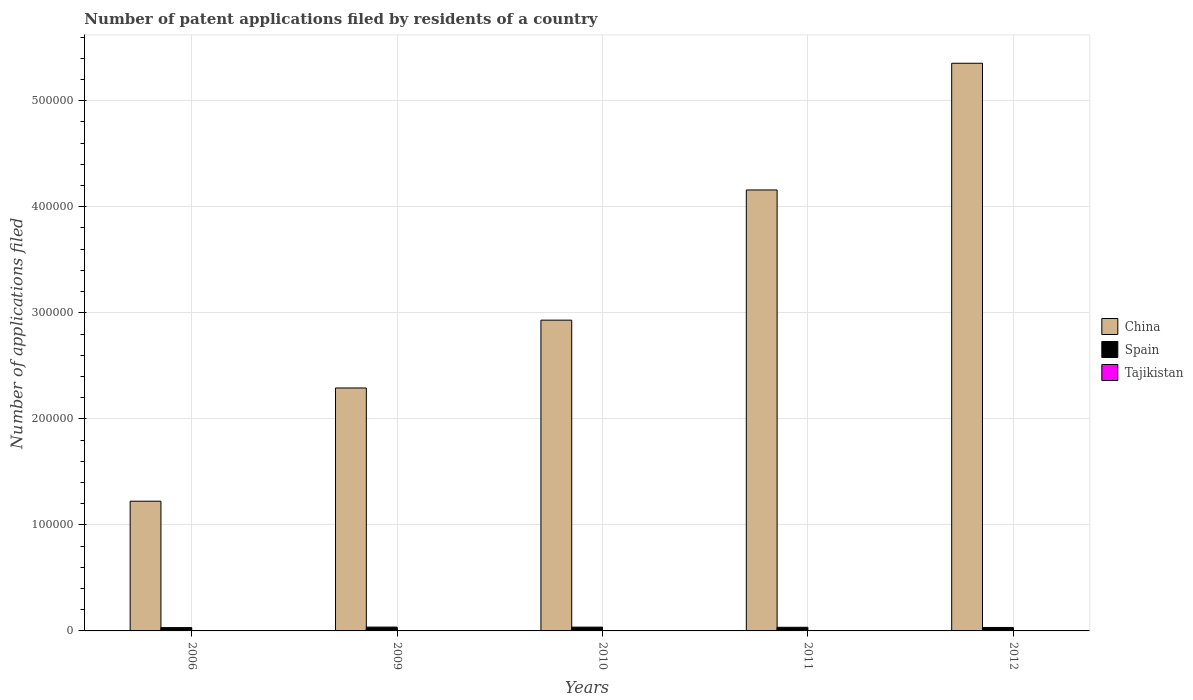How many groups of bars are there?
Your response must be concise. 5. Are the number of bars on each tick of the X-axis equal?
Your answer should be compact. Yes. What is the number of applications filed in China in 2010?
Offer a very short reply. 2.93e+05. Across all years, what is the maximum number of applications filed in China?
Offer a very short reply. 5.35e+05. Across all years, what is the minimum number of applications filed in China?
Provide a short and direct response. 1.22e+05. In which year was the number of applications filed in Spain maximum?
Keep it short and to the point. 2009. In which year was the number of applications filed in Spain minimum?
Make the answer very short. 2006. What is the total number of applications filed in Spain in the graph?
Offer a very short reply. 1.70e+04. What is the difference between the number of applications filed in China in 2009 and that in 2011?
Your answer should be very brief. -1.87e+05. What is the difference between the number of applications filed in Spain in 2011 and the number of applications filed in Tajikistan in 2010?
Provide a short and direct response. 3423. What is the average number of applications filed in China per year?
Make the answer very short. 3.19e+05. In the year 2006, what is the difference between the number of applications filed in China and number of applications filed in Tajikistan?
Offer a terse response. 1.22e+05. In how many years, is the number of applications filed in Spain greater than 60000?
Offer a terse response. 0. What is the ratio of the number of applications filed in Spain in 2011 to that in 2012?
Keep it short and to the point. 1.05. Is the number of applications filed in Tajikistan in 2009 less than that in 2011?
Your answer should be compact. No. Is the difference between the number of applications filed in China in 2006 and 2009 greater than the difference between the number of applications filed in Tajikistan in 2006 and 2009?
Provide a short and direct response. No. What is the difference between the highest and the second highest number of applications filed in China?
Ensure brevity in your answer.  1.19e+05. What is the difference between the highest and the lowest number of applications filed in Tajikistan?
Ensure brevity in your answer.  23. What does the 1st bar from the right in 2006 represents?
Make the answer very short. Tajikistan. How many bars are there?
Your answer should be compact. 15. How many years are there in the graph?
Offer a terse response. 5. What is the difference between two consecutive major ticks on the Y-axis?
Keep it short and to the point. 1.00e+05. Does the graph contain any zero values?
Your response must be concise. No. Where does the legend appear in the graph?
Your answer should be compact. Center right. What is the title of the graph?
Give a very brief answer. Number of patent applications filed by residents of a country. What is the label or title of the X-axis?
Offer a terse response. Years. What is the label or title of the Y-axis?
Offer a terse response. Number of applications filed. What is the Number of applications filed of China in 2006?
Your response must be concise. 1.22e+05. What is the Number of applications filed of Spain in 2006?
Provide a succinct answer. 3111. What is the Number of applications filed of Tajikistan in 2006?
Make the answer very short. 26. What is the Number of applications filed in China in 2009?
Provide a short and direct response. 2.29e+05. What is the Number of applications filed of Spain in 2009?
Your answer should be very brief. 3596. What is the Number of applications filed in China in 2010?
Provide a succinct answer. 2.93e+05. What is the Number of applications filed in Spain in 2010?
Keep it short and to the point. 3566. What is the Number of applications filed of Tajikistan in 2010?
Your answer should be compact. 7. What is the Number of applications filed of China in 2011?
Offer a terse response. 4.16e+05. What is the Number of applications filed of Spain in 2011?
Provide a short and direct response. 3430. What is the Number of applications filed of Tajikistan in 2011?
Provide a short and direct response. 4. What is the Number of applications filed of China in 2012?
Offer a very short reply. 5.35e+05. What is the Number of applications filed in Spain in 2012?
Give a very brief answer. 3266. What is the Number of applications filed of Tajikistan in 2012?
Provide a short and direct response. 3. Across all years, what is the maximum Number of applications filed of China?
Provide a succinct answer. 5.35e+05. Across all years, what is the maximum Number of applications filed of Spain?
Offer a terse response. 3596. Across all years, what is the maximum Number of applications filed of Tajikistan?
Offer a terse response. 26. Across all years, what is the minimum Number of applications filed in China?
Provide a short and direct response. 1.22e+05. Across all years, what is the minimum Number of applications filed in Spain?
Provide a short and direct response. 3111. What is the total Number of applications filed of China in the graph?
Offer a very short reply. 1.60e+06. What is the total Number of applications filed in Spain in the graph?
Provide a short and direct response. 1.70e+04. What is the total Number of applications filed of Tajikistan in the graph?
Offer a very short reply. 51. What is the difference between the Number of applications filed of China in 2006 and that in 2009?
Make the answer very short. -1.07e+05. What is the difference between the Number of applications filed of Spain in 2006 and that in 2009?
Provide a short and direct response. -485. What is the difference between the Number of applications filed of China in 2006 and that in 2010?
Offer a terse response. -1.71e+05. What is the difference between the Number of applications filed in Spain in 2006 and that in 2010?
Your answer should be compact. -455. What is the difference between the Number of applications filed in China in 2006 and that in 2011?
Your answer should be compact. -2.94e+05. What is the difference between the Number of applications filed of Spain in 2006 and that in 2011?
Provide a short and direct response. -319. What is the difference between the Number of applications filed of China in 2006 and that in 2012?
Keep it short and to the point. -4.13e+05. What is the difference between the Number of applications filed in Spain in 2006 and that in 2012?
Ensure brevity in your answer.  -155. What is the difference between the Number of applications filed in Tajikistan in 2006 and that in 2012?
Ensure brevity in your answer.  23. What is the difference between the Number of applications filed in China in 2009 and that in 2010?
Offer a terse response. -6.40e+04. What is the difference between the Number of applications filed of Tajikistan in 2009 and that in 2010?
Offer a very short reply. 4. What is the difference between the Number of applications filed in China in 2009 and that in 2011?
Make the answer very short. -1.87e+05. What is the difference between the Number of applications filed in Spain in 2009 and that in 2011?
Offer a very short reply. 166. What is the difference between the Number of applications filed of China in 2009 and that in 2012?
Offer a terse response. -3.06e+05. What is the difference between the Number of applications filed in Spain in 2009 and that in 2012?
Provide a succinct answer. 330. What is the difference between the Number of applications filed in China in 2010 and that in 2011?
Offer a terse response. -1.23e+05. What is the difference between the Number of applications filed in Spain in 2010 and that in 2011?
Provide a short and direct response. 136. What is the difference between the Number of applications filed in China in 2010 and that in 2012?
Offer a very short reply. -2.42e+05. What is the difference between the Number of applications filed in Spain in 2010 and that in 2012?
Your answer should be compact. 300. What is the difference between the Number of applications filed in Tajikistan in 2010 and that in 2012?
Offer a very short reply. 4. What is the difference between the Number of applications filed in China in 2011 and that in 2012?
Keep it short and to the point. -1.19e+05. What is the difference between the Number of applications filed of Spain in 2011 and that in 2012?
Your answer should be very brief. 164. What is the difference between the Number of applications filed of Tajikistan in 2011 and that in 2012?
Your answer should be very brief. 1. What is the difference between the Number of applications filed of China in 2006 and the Number of applications filed of Spain in 2009?
Your answer should be very brief. 1.19e+05. What is the difference between the Number of applications filed of China in 2006 and the Number of applications filed of Tajikistan in 2009?
Offer a terse response. 1.22e+05. What is the difference between the Number of applications filed in Spain in 2006 and the Number of applications filed in Tajikistan in 2009?
Make the answer very short. 3100. What is the difference between the Number of applications filed of China in 2006 and the Number of applications filed of Spain in 2010?
Offer a terse response. 1.19e+05. What is the difference between the Number of applications filed of China in 2006 and the Number of applications filed of Tajikistan in 2010?
Ensure brevity in your answer.  1.22e+05. What is the difference between the Number of applications filed in Spain in 2006 and the Number of applications filed in Tajikistan in 2010?
Make the answer very short. 3104. What is the difference between the Number of applications filed of China in 2006 and the Number of applications filed of Spain in 2011?
Ensure brevity in your answer.  1.19e+05. What is the difference between the Number of applications filed in China in 2006 and the Number of applications filed in Tajikistan in 2011?
Make the answer very short. 1.22e+05. What is the difference between the Number of applications filed in Spain in 2006 and the Number of applications filed in Tajikistan in 2011?
Keep it short and to the point. 3107. What is the difference between the Number of applications filed in China in 2006 and the Number of applications filed in Spain in 2012?
Your answer should be compact. 1.19e+05. What is the difference between the Number of applications filed of China in 2006 and the Number of applications filed of Tajikistan in 2012?
Ensure brevity in your answer.  1.22e+05. What is the difference between the Number of applications filed in Spain in 2006 and the Number of applications filed in Tajikistan in 2012?
Provide a succinct answer. 3108. What is the difference between the Number of applications filed in China in 2009 and the Number of applications filed in Spain in 2010?
Offer a terse response. 2.26e+05. What is the difference between the Number of applications filed of China in 2009 and the Number of applications filed of Tajikistan in 2010?
Ensure brevity in your answer.  2.29e+05. What is the difference between the Number of applications filed of Spain in 2009 and the Number of applications filed of Tajikistan in 2010?
Your response must be concise. 3589. What is the difference between the Number of applications filed of China in 2009 and the Number of applications filed of Spain in 2011?
Provide a succinct answer. 2.26e+05. What is the difference between the Number of applications filed of China in 2009 and the Number of applications filed of Tajikistan in 2011?
Your answer should be compact. 2.29e+05. What is the difference between the Number of applications filed of Spain in 2009 and the Number of applications filed of Tajikistan in 2011?
Your response must be concise. 3592. What is the difference between the Number of applications filed of China in 2009 and the Number of applications filed of Spain in 2012?
Make the answer very short. 2.26e+05. What is the difference between the Number of applications filed in China in 2009 and the Number of applications filed in Tajikistan in 2012?
Your answer should be very brief. 2.29e+05. What is the difference between the Number of applications filed of Spain in 2009 and the Number of applications filed of Tajikistan in 2012?
Provide a succinct answer. 3593. What is the difference between the Number of applications filed in China in 2010 and the Number of applications filed in Spain in 2011?
Your answer should be compact. 2.90e+05. What is the difference between the Number of applications filed of China in 2010 and the Number of applications filed of Tajikistan in 2011?
Your answer should be compact. 2.93e+05. What is the difference between the Number of applications filed of Spain in 2010 and the Number of applications filed of Tajikistan in 2011?
Offer a terse response. 3562. What is the difference between the Number of applications filed in China in 2010 and the Number of applications filed in Spain in 2012?
Provide a short and direct response. 2.90e+05. What is the difference between the Number of applications filed in China in 2010 and the Number of applications filed in Tajikistan in 2012?
Keep it short and to the point. 2.93e+05. What is the difference between the Number of applications filed of Spain in 2010 and the Number of applications filed of Tajikistan in 2012?
Your response must be concise. 3563. What is the difference between the Number of applications filed in China in 2011 and the Number of applications filed in Spain in 2012?
Offer a very short reply. 4.13e+05. What is the difference between the Number of applications filed of China in 2011 and the Number of applications filed of Tajikistan in 2012?
Ensure brevity in your answer.  4.16e+05. What is the difference between the Number of applications filed in Spain in 2011 and the Number of applications filed in Tajikistan in 2012?
Make the answer very short. 3427. What is the average Number of applications filed in China per year?
Give a very brief answer. 3.19e+05. What is the average Number of applications filed of Spain per year?
Provide a succinct answer. 3393.8. What is the average Number of applications filed in Tajikistan per year?
Provide a succinct answer. 10.2. In the year 2006, what is the difference between the Number of applications filed of China and Number of applications filed of Spain?
Offer a very short reply. 1.19e+05. In the year 2006, what is the difference between the Number of applications filed of China and Number of applications filed of Tajikistan?
Provide a succinct answer. 1.22e+05. In the year 2006, what is the difference between the Number of applications filed in Spain and Number of applications filed in Tajikistan?
Offer a very short reply. 3085. In the year 2009, what is the difference between the Number of applications filed of China and Number of applications filed of Spain?
Your response must be concise. 2.26e+05. In the year 2009, what is the difference between the Number of applications filed of China and Number of applications filed of Tajikistan?
Your answer should be very brief. 2.29e+05. In the year 2009, what is the difference between the Number of applications filed in Spain and Number of applications filed in Tajikistan?
Your answer should be compact. 3585. In the year 2010, what is the difference between the Number of applications filed in China and Number of applications filed in Spain?
Offer a very short reply. 2.90e+05. In the year 2010, what is the difference between the Number of applications filed of China and Number of applications filed of Tajikistan?
Provide a short and direct response. 2.93e+05. In the year 2010, what is the difference between the Number of applications filed of Spain and Number of applications filed of Tajikistan?
Make the answer very short. 3559. In the year 2011, what is the difference between the Number of applications filed of China and Number of applications filed of Spain?
Your answer should be compact. 4.12e+05. In the year 2011, what is the difference between the Number of applications filed in China and Number of applications filed in Tajikistan?
Offer a terse response. 4.16e+05. In the year 2011, what is the difference between the Number of applications filed in Spain and Number of applications filed in Tajikistan?
Keep it short and to the point. 3426. In the year 2012, what is the difference between the Number of applications filed in China and Number of applications filed in Spain?
Your answer should be very brief. 5.32e+05. In the year 2012, what is the difference between the Number of applications filed in China and Number of applications filed in Tajikistan?
Ensure brevity in your answer.  5.35e+05. In the year 2012, what is the difference between the Number of applications filed in Spain and Number of applications filed in Tajikistan?
Keep it short and to the point. 3263. What is the ratio of the Number of applications filed in China in 2006 to that in 2009?
Provide a short and direct response. 0.53. What is the ratio of the Number of applications filed in Spain in 2006 to that in 2009?
Your answer should be compact. 0.87. What is the ratio of the Number of applications filed in Tajikistan in 2006 to that in 2009?
Make the answer very short. 2.36. What is the ratio of the Number of applications filed in China in 2006 to that in 2010?
Provide a short and direct response. 0.42. What is the ratio of the Number of applications filed in Spain in 2006 to that in 2010?
Your answer should be very brief. 0.87. What is the ratio of the Number of applications filed in Tajikistan in 2006 to that in 2010?
Keep it short and to the point. 3.71. What is the ratio of the Number of applications filed of China in 2006 to that in 2011?
Make the answer very short. 0.29. What is the ratio of the Number of applications filed in Spain in 2006 to that in 2011?
Offer a very short reply. 0.91. What is the ratio of the Number of applications filed in Tajikistan in 2006 to that in 2011?
Your answer should be very brief. 6.5. What is the ratio of the Number of applications filed of China in 2006 to that in 2012?
Your answer should be compact. 0.23. What is the ratio of the Number of applications filed in Spain in 2006 to that in 2012?
Ensure brevity in your answer.  0.95. What is the ratio of the Number of applications filed in Tajikistan in 2006 to that in 2012?
Your response must be concise. 8.67. What is the ratio of the Number of applications filed of China in 2009 to that in 2010?
Ensure brevity in your answer.  0.78. What is the ratio of the Number of applications filed in Spain in 2009 to that in 2010?
Provide a short and direct response. 1.01. What is the ratio of the Number of applications filed of Tajikistan in 2009 to that in 2010?
Your response must be concise. 1.57. What is the ratio of the Number of applications filed of China in 2009 to that in 2011?
Your answer should be compact. 0.55. What is the ratio of the Number of applications filed of Spain in 2009 to that in 2011?
Offer a very short reply. 1.05. What is the ratio of the Number of applications filed in Tajikistan in 2009 to that in 2011?
Your answer should be compact. 2.75. What is the ratio of the Number of applications filed in China in 2009 to that in 2012?
Your answer should be very brief. 0.43. What is the ratio of the Number of applications filed in Spain in 2009 to that in 2012?
Ensure brevity in your answer.  1.1. What is the ratio of the Number of applications filed in Tajikistan in 2009 to that in 2012?
Give a very brief answer. 3.67. What is the ratio of the Number of applications filed in China in 2010 to that in 2011?
Provide a succinct answer. 0.7. What is the ratio of the Number of applications filed of Spain in 2010 to that in 2011?
Ensure brevity in your answer.  1.04. What is the ratio of the Number of applications filed in Tajikistan in 2010 to that in 2011?
Your response must be concise. 1.75. What is the ratio of the Number of applications filed of China in 2010 to that in 2012?
Ensure brevity in your answer.  0.55. What is the ratio of the Number of applications filed of Spain in 2010 to that in 2012?
Keep it short and to the point. 1.09. What is the ratio of the Number of applications filed in Tajikistan in 2010 to that in 2012?
Offer a very short reply. 2.33. What is the ratio of the Number of applications filed of China in 2011 to that in 2012?
Ensure brevity in your answer.  0.78. What is the ratio of the Number of applications filed of Spain in 2011 to that in 2012?
Provide a short and direct response. 1.05. What is the ratio of the Number of applications filed in Tajikistan in 2011 to that in 2012?
Make the answer very short. 1.33. What is the difference between the highest and the second highest Number of applications filed of China?
Your answer should be very brief. 1.19e+05. What is the difference between the highest and the second highest Number of applications filed in Tajikistan?
Give a very brief answer. 15. What is the difference between the highest and the lowest Number of applications filed of China?
Offer a terse response. 4.13e+05. What is the difference between the highest and the lowest Number of applications filed in Spain?
Make the answer very short. 485. 